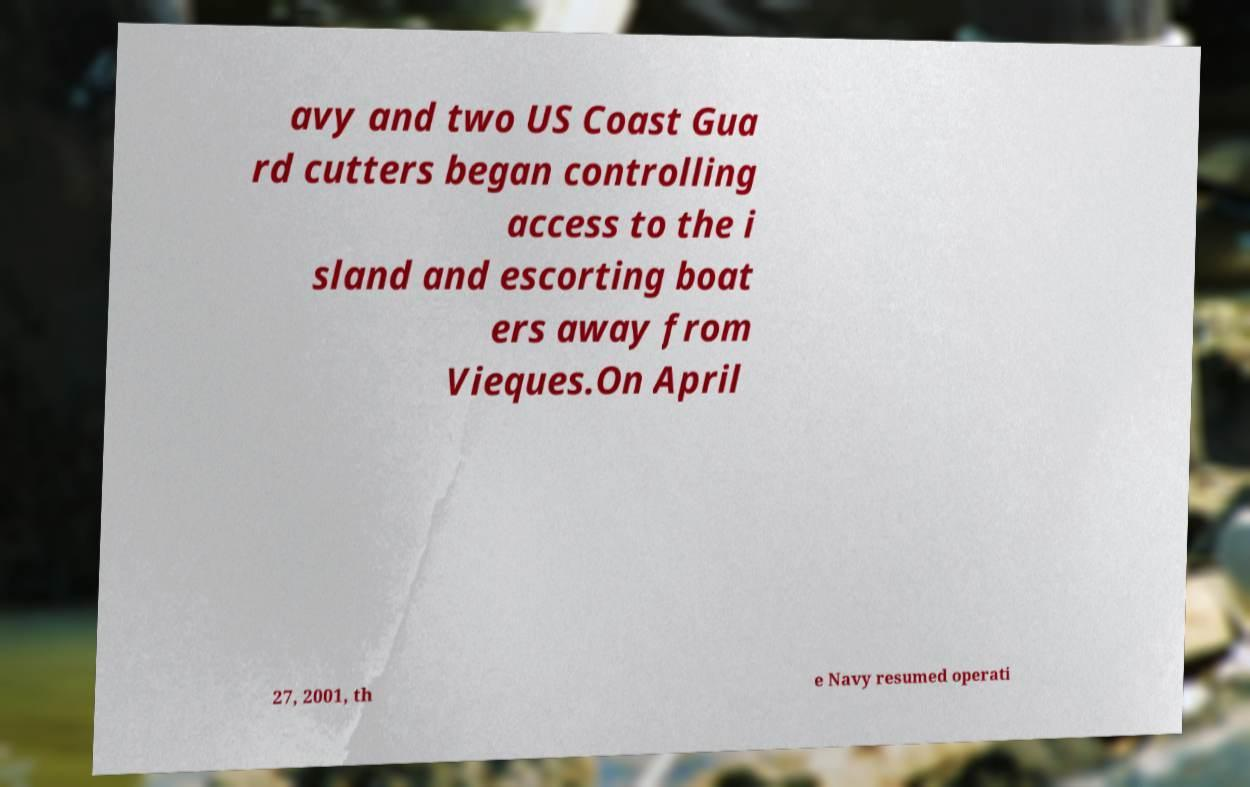Please read and relay the text visible in this image. What does it say? avy and two US Coast Gua rd cutters began controlling access to the i sland and escorting boat ers away from Vieques.On April 27, 2001, th e Navy resumed operati 